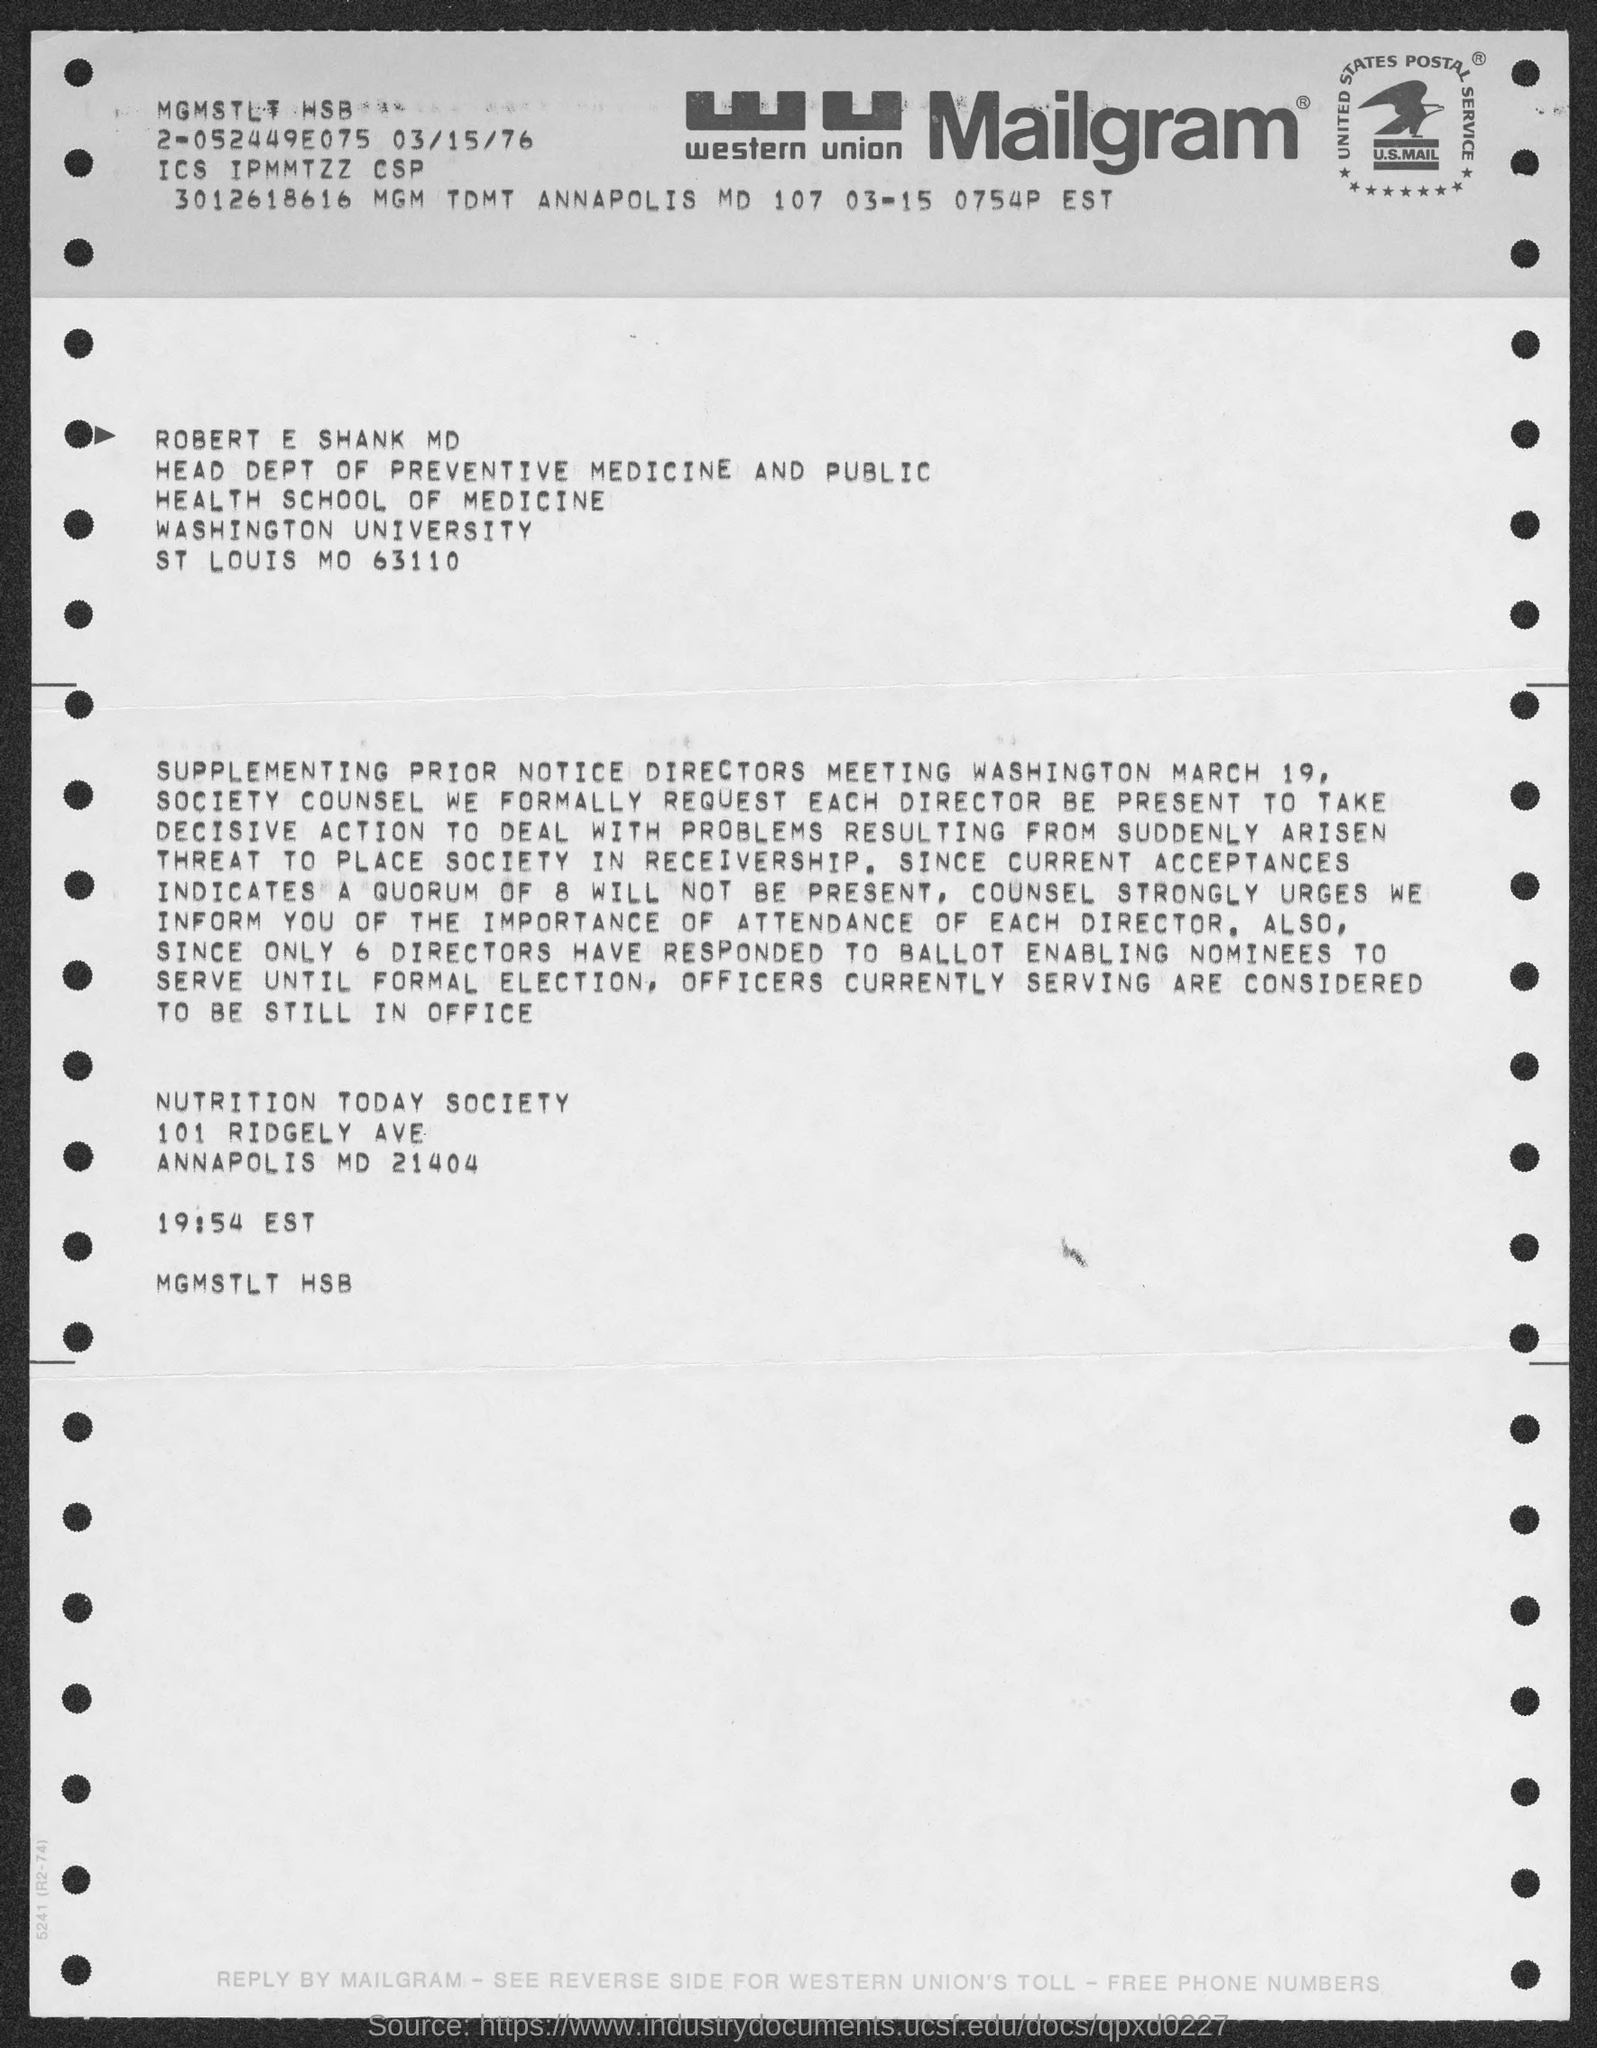Give some essential details in this illustration. The communication in question is Mailgram, a type of communication that involves sending messages through the mail. The individual named ROBERT E. SHANK MD is the Head of the Department of Preventive Medicine and Public Health. 